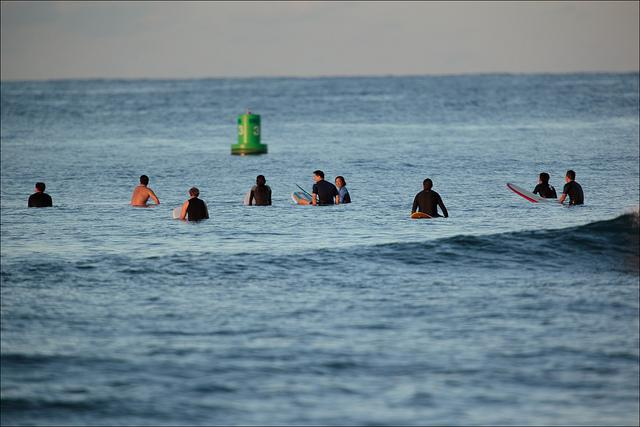Where are the people hanging out? Please explain your reasoning. water. The people are by the water. 